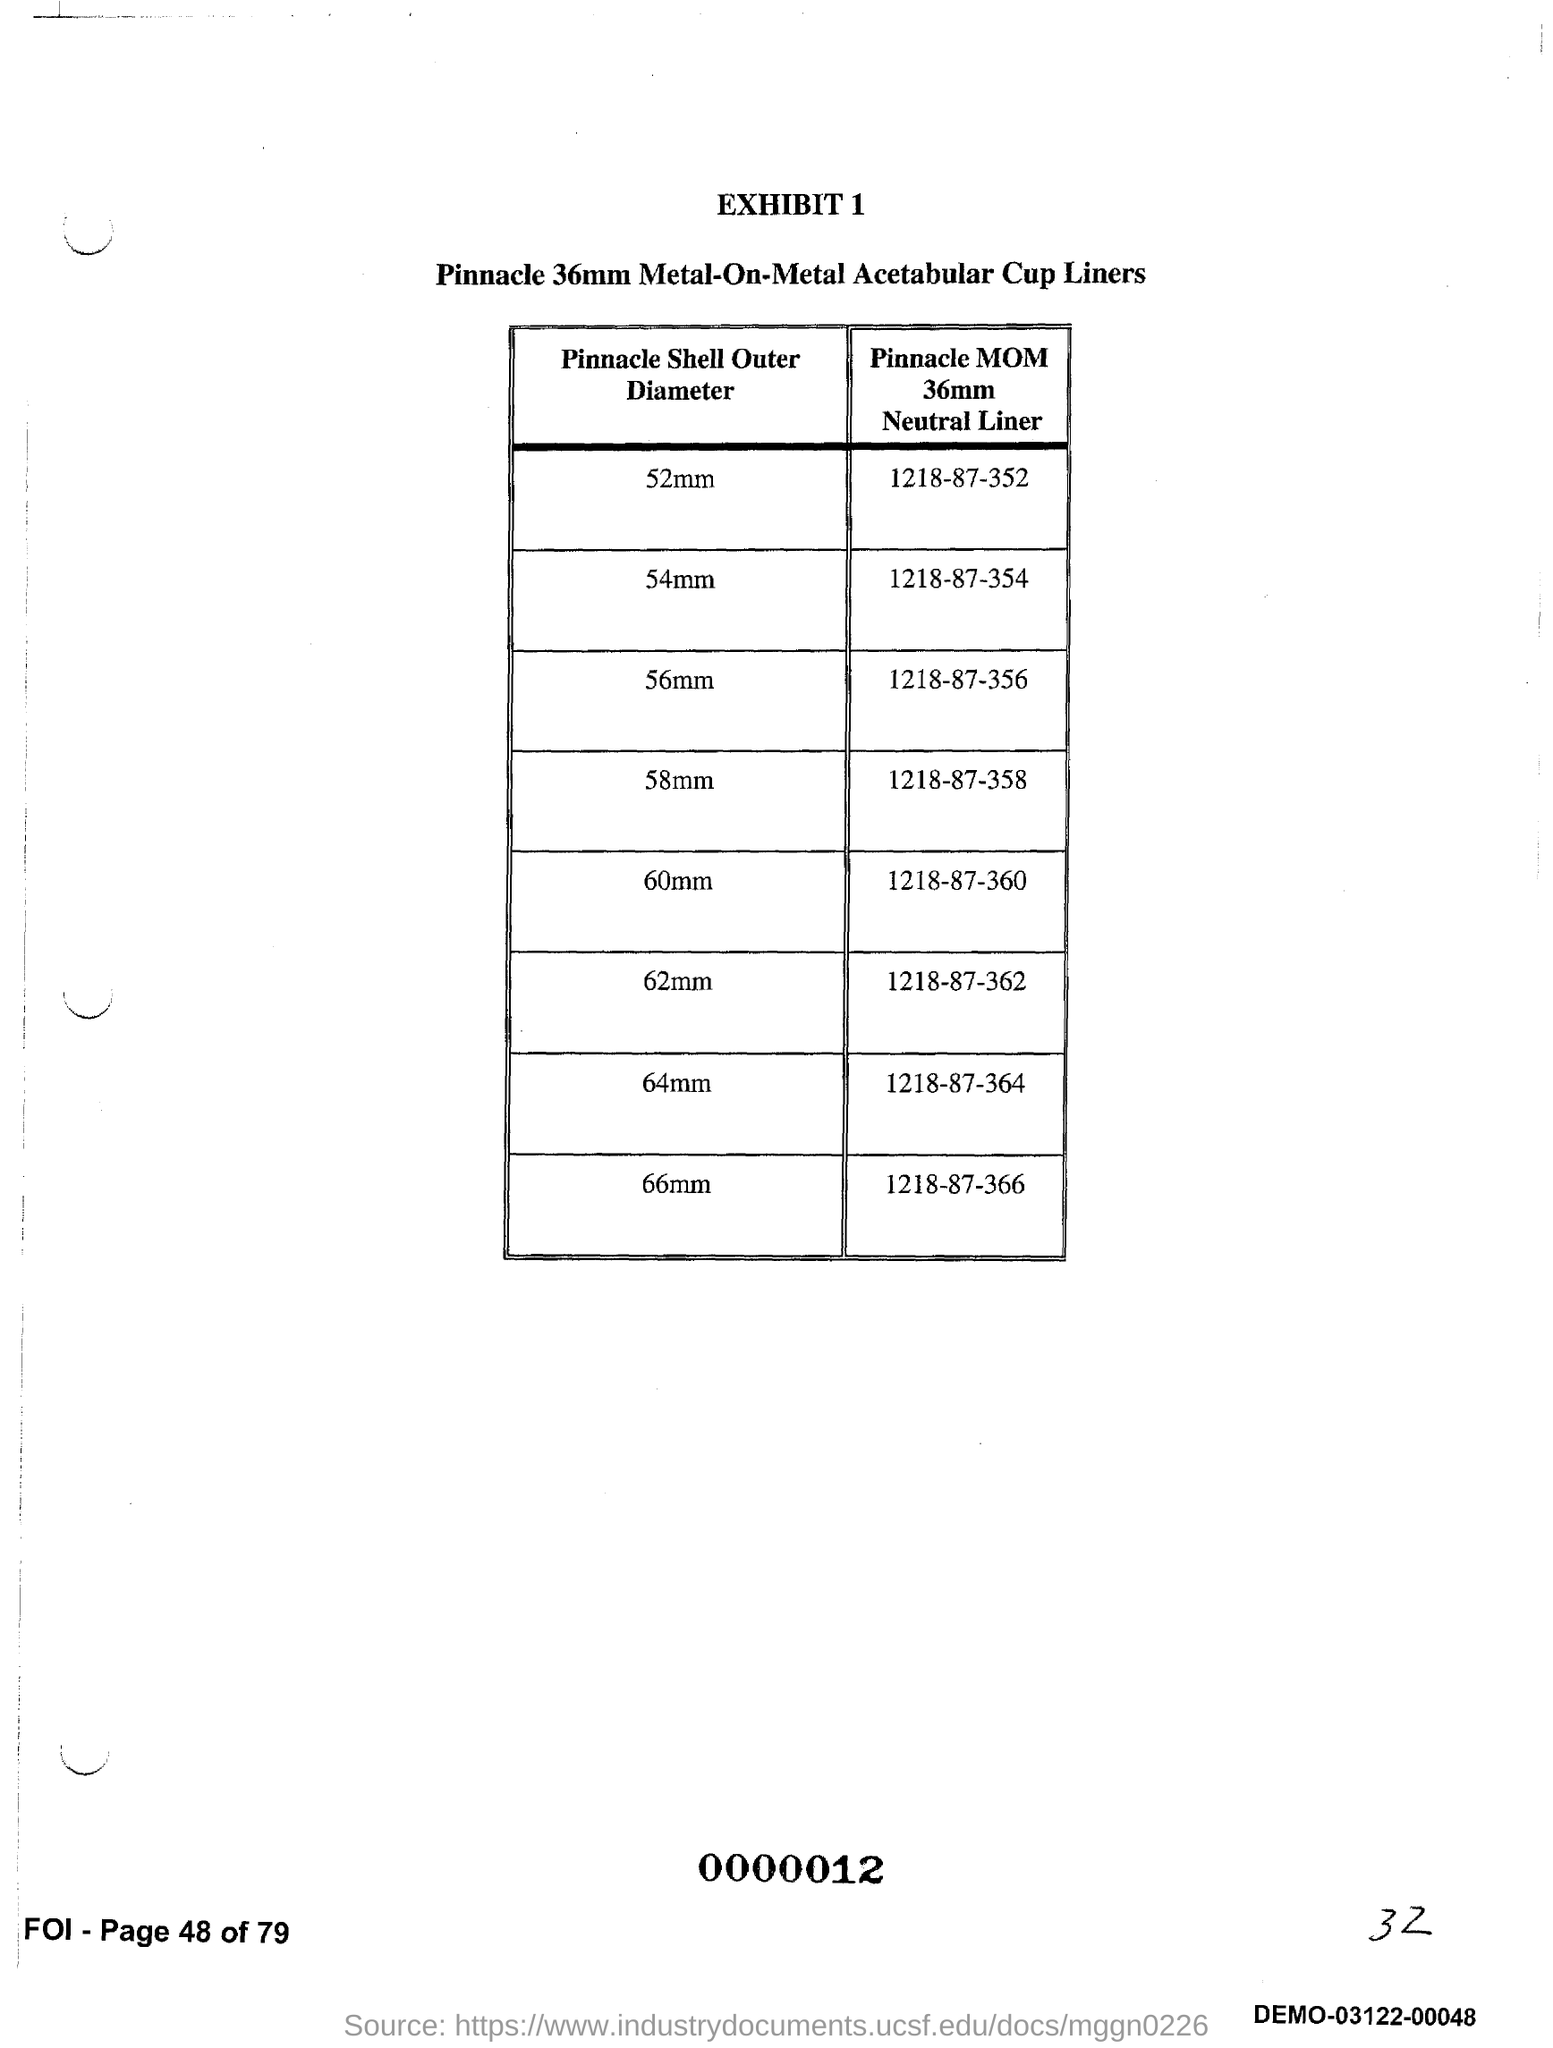Specify some key components in this picture. What is the Exhibit number?" is a question asking for information. 